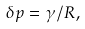<formula> <loc_0><loc_0><loc_500><loc_500>\delta p = \gamma / R ,</formula> 